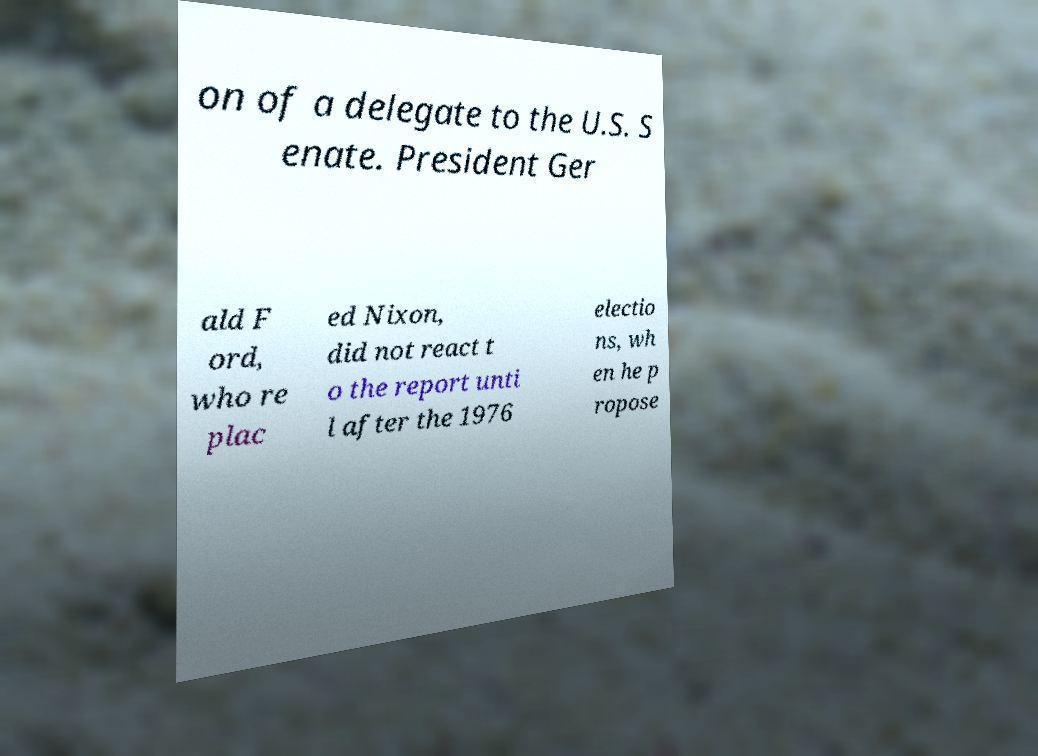What messages or text are displayed in this image? I need them in a readable, typed format. on of a delegate to the U.S. S enate. President Ger ald F ord, who re plac ed Nixon, did not react t o the report unti l after the 1976 electio ns, wh en he p ropose 